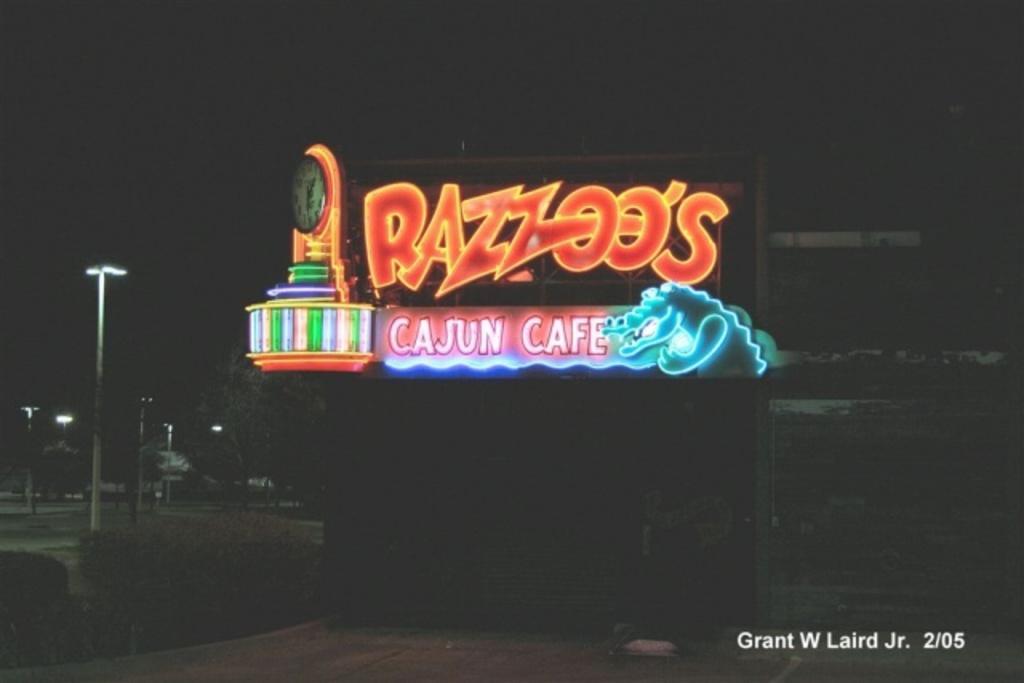Could you give a brief overview of what you see in this image? There is an advertising text board is present in the middle of this image. We can see trees and poles on the left side of this image and it is dark in the background. There is a watermark in the bottom right corner of this image. 